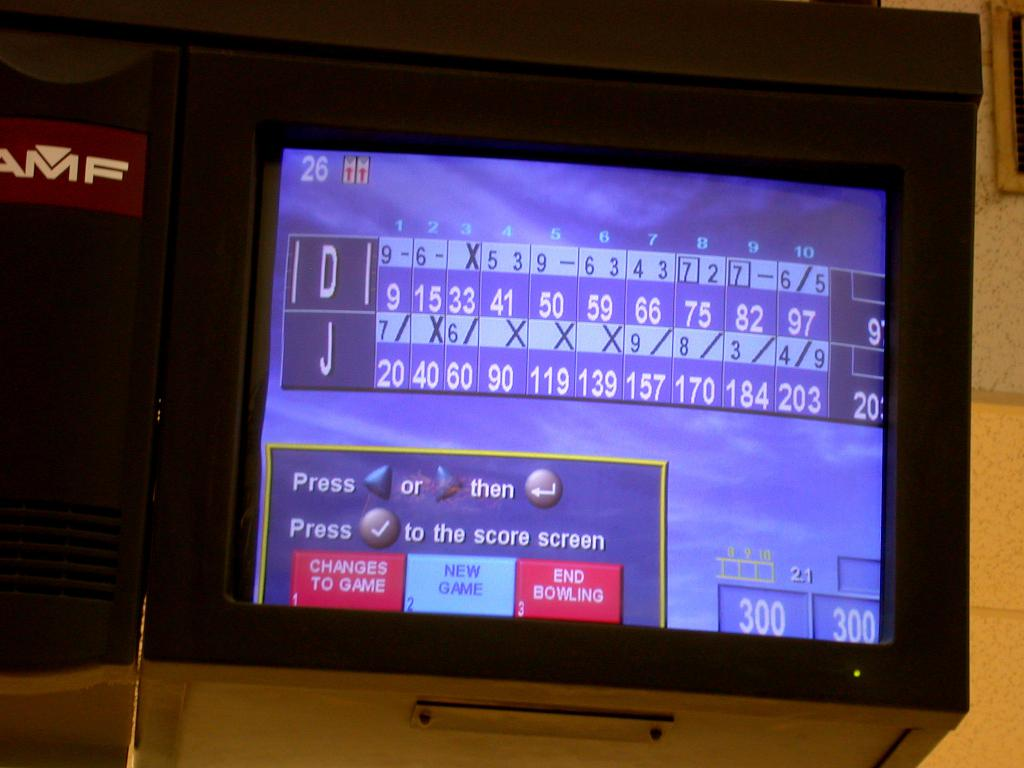Provide a one-sentence caption for the provided image. The image displays a digital scoreboard for a bowling game, showing individual frame scores and player initials, with interactive menu options for altering the current game or starting a new one. 